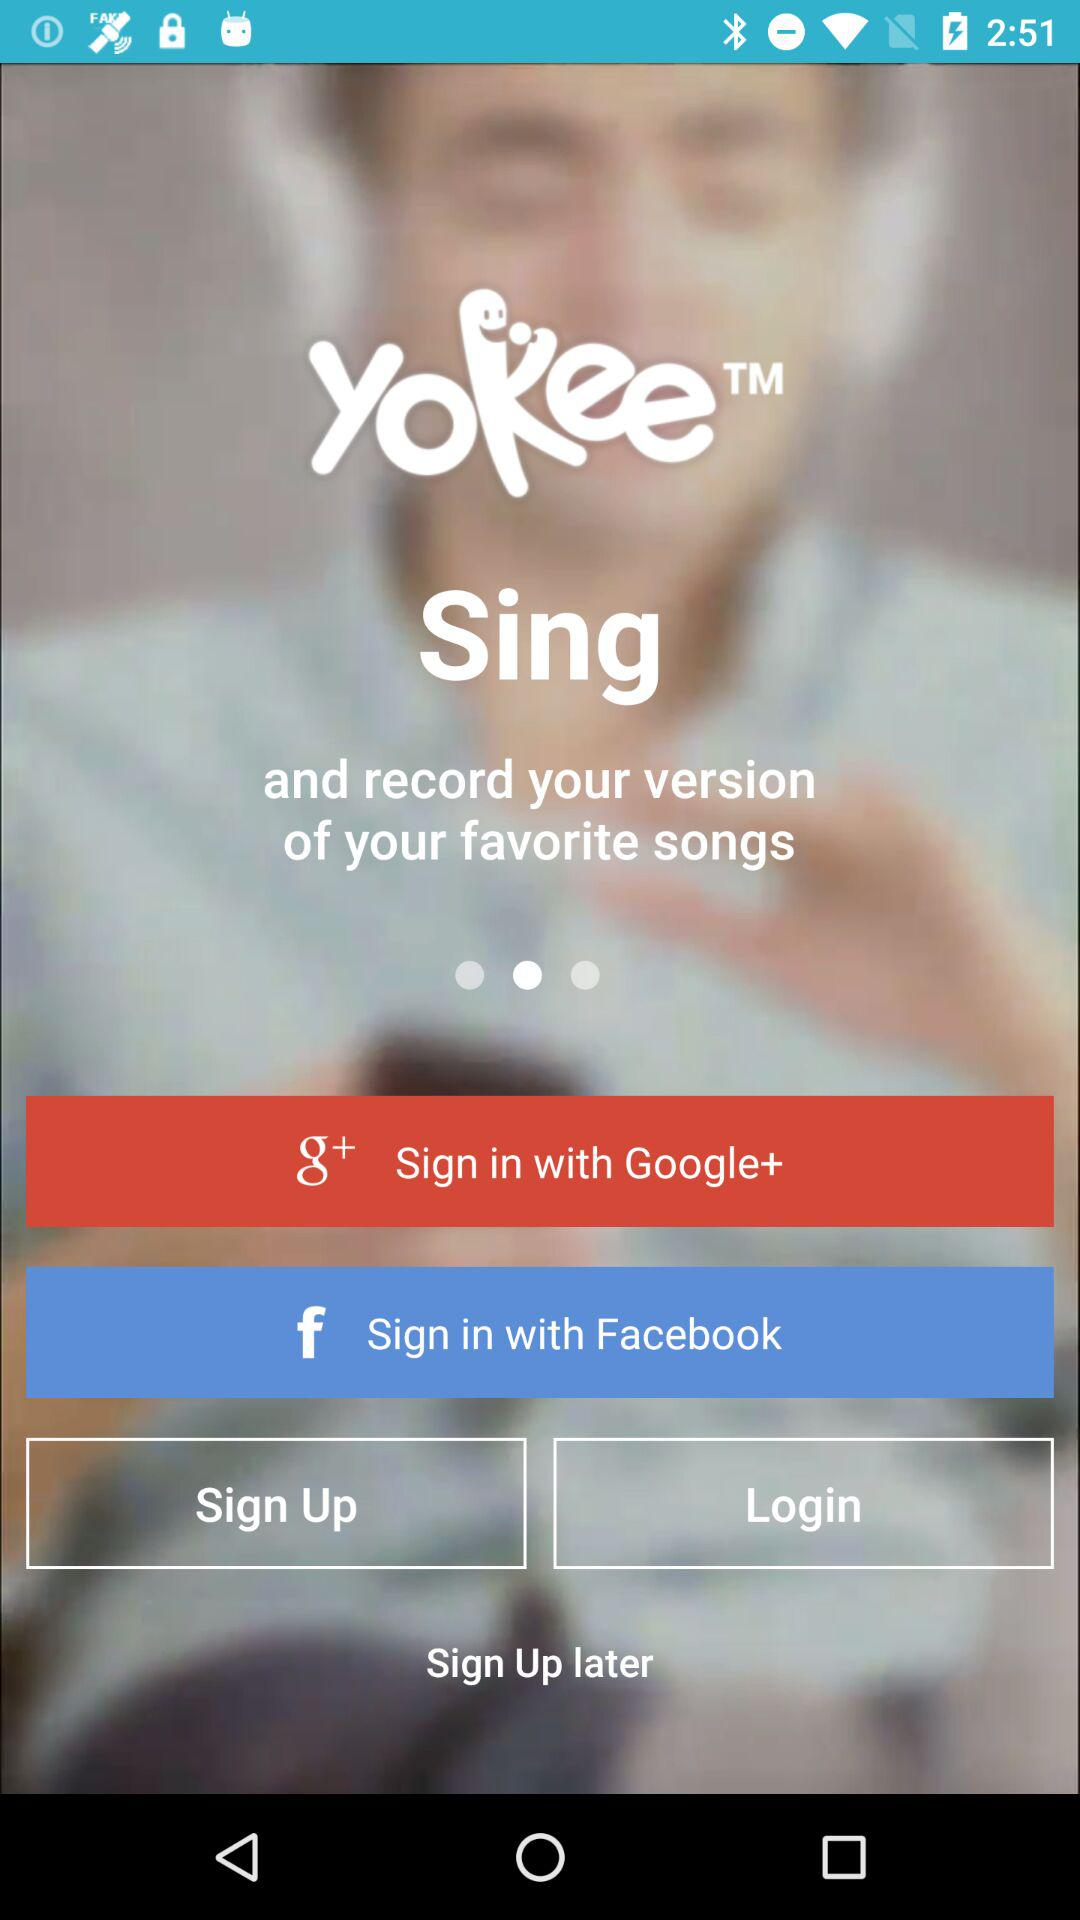What are the sign-in options? The sign-in options are "Google+" and "Facebook". 